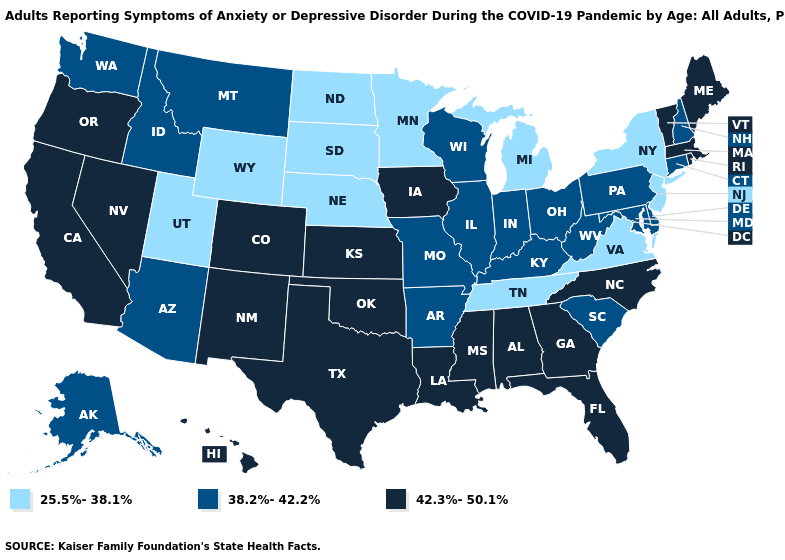What is the value of Ohio?
Be succinct. 38.2%-42.2%. Does Arkansas have the highest value in the USA?
Write a very short answer. No. What is the value of Maryland?
Write a very short answer. 38.2%-42.2%. Which states have the lowest value in the West?
Be succinct. Utah, Wyoming. What is the highest value in the USA?
Answer briefly. 42.3%-50.1%. Does New Mexico have the same value as Arizona?
Concise answer only. No. What is the lowest value in the South?
Give a very brief answer. 25.5%-38.1%. What is the value of New Hampshire?
Concise answer only. 38.2%-42.2%. What is the value of Montana?
Quick response, please. 38.2%-42.2%. Among the states that border Vermont , which have the lowest value?
Answer briefly. New York. Does Kansas have a lower value than Nevada?
Write a very short answer. No. Which states have the lowest value in the USA?
Give a very brief answer. Michigan, Minnesota, Nebraska, New Jersey, New York, North Dakota, South Dakota, Tennessee, Utah, Virginia, Wyoming. Name the states that have a value in the range 38.2%-42.2%?
Keep it brief. Alaska, Arizona, Arkansas, Connecticut, Delaware, Idaho, Illinois, Indiana, Kentucky, Maryland, Missouri, Montana, New Hampshire, Ohio, Pennsylvania, South Carolina, Washington, West Virginia, Wisconsin. What is the value of Pennsylvania?
Be succinct. 38.2%-42.2%. Does Colorado have the same value as Alabama?
Concise answer only. Yes. 